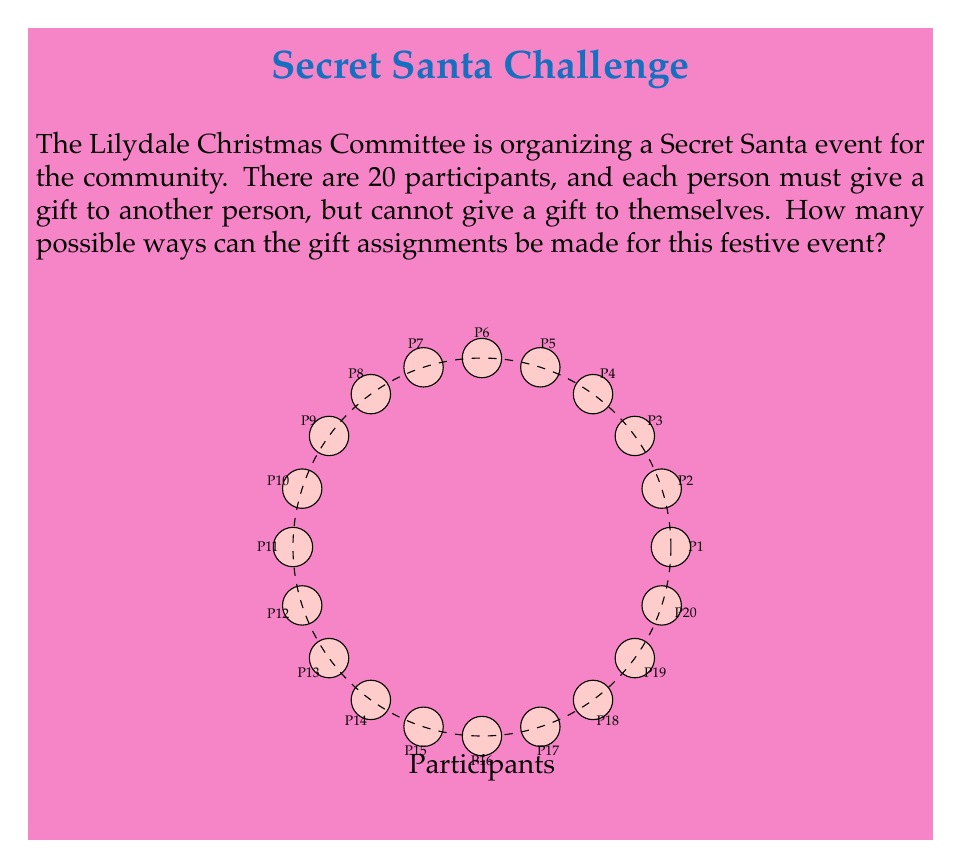Can you solve this math problem? Let's approach this step-by-step:

1) This problem is equivalent to counting the number of derangements of a set of 20 elements. A derangement is a permutation where no element appears in its original position.

2) The number of derangements of n elements is denoted by !n (the subfactorial of n).

3) The formula for calculating the number of derangements is:

   $$!n = n! \sum_{k=0}^n \frac{(-1)^k}{k!}$$

4) For n = 20, we have:

   $$!20 = 20! \sum_{k=0}^{20} \frac{(-1)^k}{k!}$$

5) Expanding this sum:

   $$!20 = 20! (1 - \frac{1}{1!} + \frac{1}{2!} - \frac{1}{3!} + ... - \frac{1}{19!} + \frac{1}{20!})$$

6) This can be approximated to:

   $$!20 \approx 20! \cdot \frac{1}{e}$$

   Where e is Euler's number (approximately 2.71828).

7) Calculating this:

   $$!20 \approx \frac{20!}{e} \approx 895014631192902121$$

8) The exact value is 895014631192902121, which is very close to our approximation.

Therefore, there are 895,014,631,192,902,121 possible ways to assign gifts in this Lilydale community Secret Santa event.
Answer: 895,014,631,192,902,121 